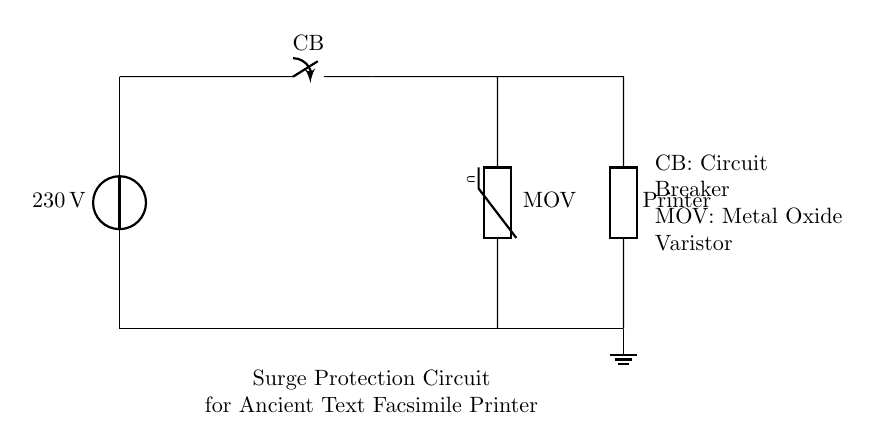What is the voltage of this circuit? The circuit is powered by a voltage source labeled as 230 volts, which indicates the potential difference supplied to the circuit.
Answer: 230 volts What does CB stand for in the circuit? The label CB in the circuit indicates that it is a circuit breaker, which is used to interrupt the flow of current in case of an overload or fault.
Answer: Circuit Breaker How many main components are visible in the circuit? The circuit diagram shows three main components: the circuit breaker, the metal oxide varistor, and the printer. Counting these gives a total of three components.
Answer: Three What is the purpose of the MOV in this circuit? The MOV, or metal oxide varistor, is used for surge protection. It limits voltage spikes to protect connected devices, like the high-capacity printer, from damage due to transients.
Answer: Surge Protection What type of load does this circuit support? The load supported by this circuit is a high-capacity printer, which is indicated by the label on one of the components.
Answer: High-capacity printer Where is the ground connection made in this circuit? The ground connection is established at the bottom of the circuit, indicated by the ground symbol, connecting to both the surge protection and the printer for safety reasons.
Answer: Bottom of the circuit Describe the flow of electricity through the circuit. Electricity flows from the voltage source through the circuit breaker to the metal oxide varistor and then to the printer. If there is an overload, the circuit breaker will open, stopping the flow.
Answer: Voltage source to circuit breaker to MOV to printer 